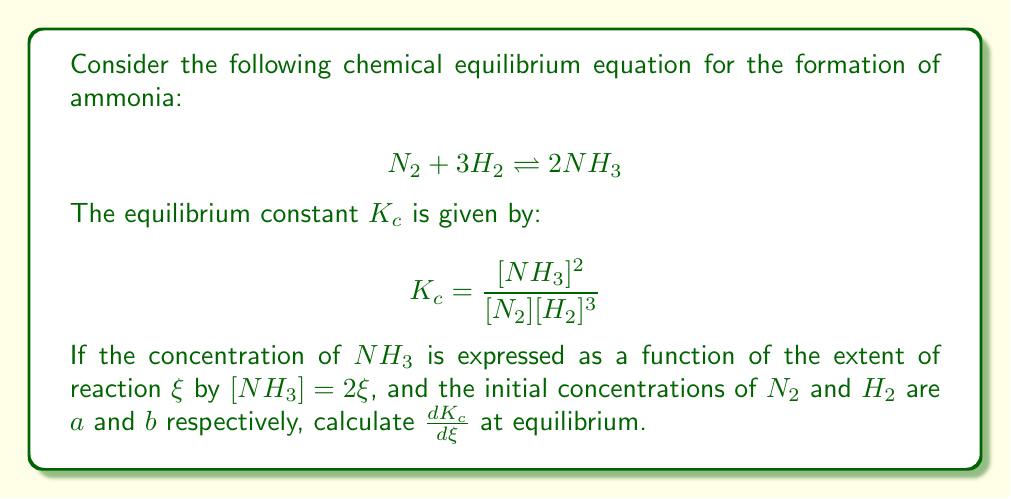Can you answer this question? Let's approach this step-by-step:

1) First, we need to express $[N_2]$ and $[H_2]$ in terms of $\xi$:
   $[N_2] = a - \xi$
   $[H_2] = b - 3\xi$

2) Now, we can rewrite $K_c$ in terms of $\xi$:

   $$ K_c = \frac{(2\xi)^2}{(a-\xi)(b-3\xi)^3} $$

3) To find $\frac{dK_c}{d\xi}$, we need to use the quotient rule:

   $$ \frac{dK_c}{d\xi} = \frac{(a-\xi)(b-3\xi)^3 \cdot \frac{d}{d\xi}(4\xi^2) - 4\xi^2 \cdot \frac{d}{d\xi}((a-\xi)(b-3\xi)^3)}{((a-\xi)(b-3\xi)^3)^2} $$

4) Let's calculate the derivatives in the numerator:
   $\frac{d}{d\xi}(4\xi^2) = 8\xi$
   
   $\frac{d}{d\xi}((a-\xi)(b-3\xi)^3) = -(b-3\xi)^3 + 3(a-\xi)(b-3\xi)^2 \cdot (-3)$
                                      $= -(b-3\xi)^3 - 9(a-\xi)(b-3\xi)^2$

5) Substituting these back into the equation:

   $$ \frac{dK_c}{d\xi} = \frac{(a-\xi)(b-3\xi)^3 \cdot 8\xi + 4\xi^2 \cdot [(b-3\xi)^3 + 9(a-\xi)(b-3\xi)^2]}{((a-\xi)(b-3\xi)^3)^2} $$

6) At equilibrium, $K_c$ is constant, so $\frac{dK_c}{d\xi} = 0$. This means the numerator must equal zero:

   $$(a-\xi)(b-3\xi)^3 \cdot 8\xi + 4\xi^2 \cdot [(b-3\xi)^3 + 9(a-\xi)(b-3\xi)^2] = 0$$

7) This is the condition for equilibrium in terms of $\xi$, $a$, and $b$.
Answer: $\frac{dK_c}{d\xi} = \frac{(a-\xi)(b-3\xi)^3 \cdot 8\xi + 4\xi^2 \cdot [(b-3\xi)^3 + 9(a-\xi)(b-3\xi)^2]}{((a-\xi)(b-3\xi)^3)^2}$

At equilibrium: $(a-\xi)(b-3\xi)^3 \cdot 8\xi + 4\xi^2 \cdot [(b-3\xi)^3 + 9(a-\xi)(b-3\xi)^2] = 0$ 